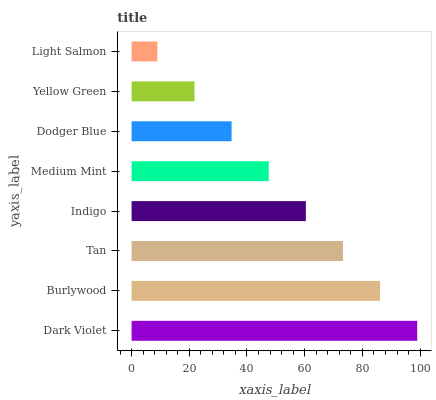Is Light Salmon the minimum?
Answer yes or no. Yes. Is Dark Violet the maximum?
Answer yes or no. Yes. Is Burlywood the minimum?
Answer yes or no. No. Is Burlywood the maximum?
Answer yes or no. No. Is Dark Violet greater than Burlywood?
Answer yes or no. Yes. Is Burlywood less than Dark Violet?
Answer yes or no. Yes. Is Burlywood greater than Dark Violet?
Answer yes or no. No. Is Dark Violet less than Burlywood?
Answer yes or no. No. Is Indigo the high median?
Answer yes or no. Yes. Is Medium Mint the low median?
Answer yes or no. Yes. Is Dodger Blue the high median?
Answer yes or no. No. Is Burlywood the low median?
Answer yes or no. No. 